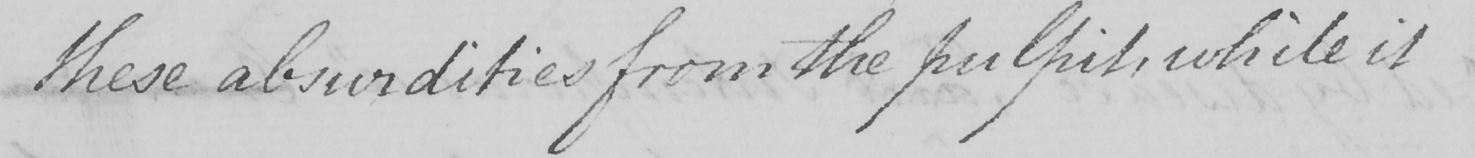Transcribe the text shown in this historical manuscript line. these absurdities from the pulpits , while it 